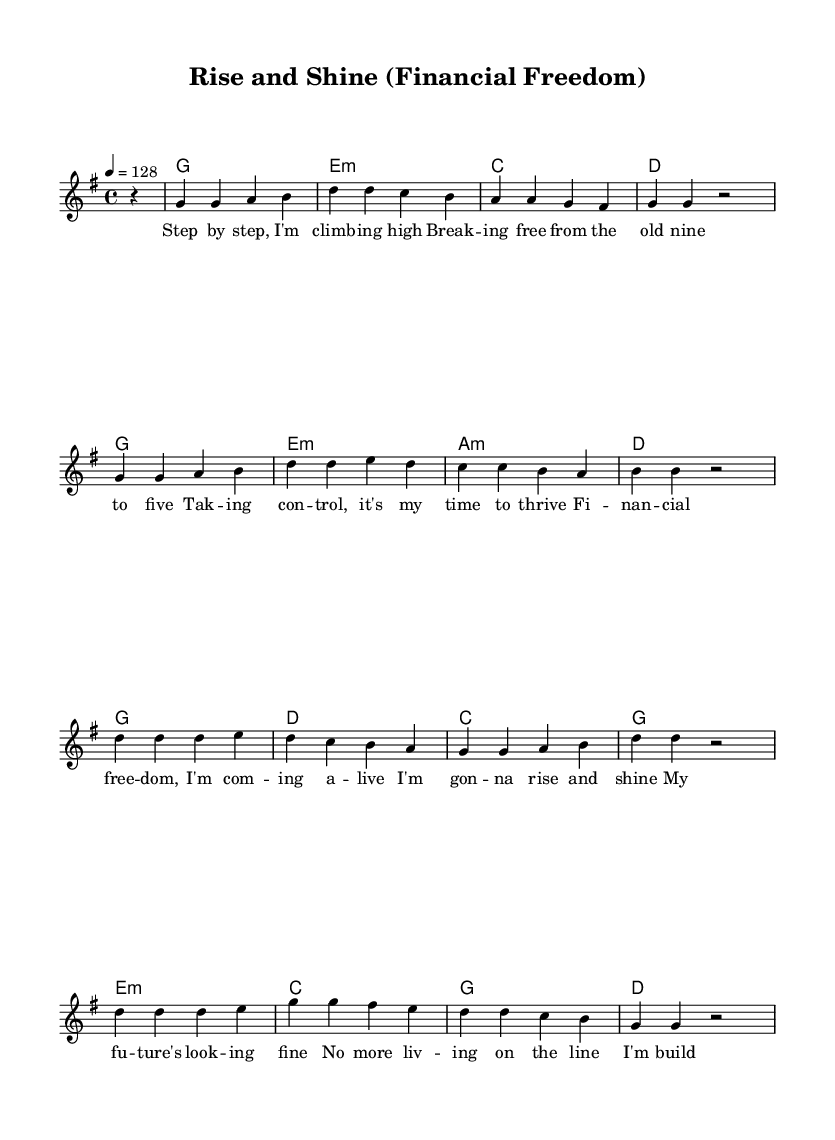What is the key signature of this music? The key signature indicates one sharp (F#), meaning the music is in G major.
Answer: G major What is the time signature of this music? The time signature is indicated by the "4/4" marking, which shows that there are four beats in each measure.
Answer: 4/4 What is the tempo marking for this piece? The tempo is notated as "4 = 128," meaning the quarter note is played at a speed of 128 beats per minute.
Answer: 128 How many measures are in the melody? Counting the measures in the melody reveals there are 8 distinct measures.
Answer: 8 What is the title of this piece? The title is located at the top of the score, clearly labeled as "Rise and Shine (Financial Freedom)."
Answer: Rise and Shine (Financial Freedom) What is the first lyric line of the song? The first lyric is provided in the lyrics section below the melody, which begins with "Step by step, I'm climb -- ing high."
Answer: Step by step, I'm climbing high Which chord is played at the start of the music? The first chord notated is a G major chord, as seen in the harmonies section.
Answer: G 